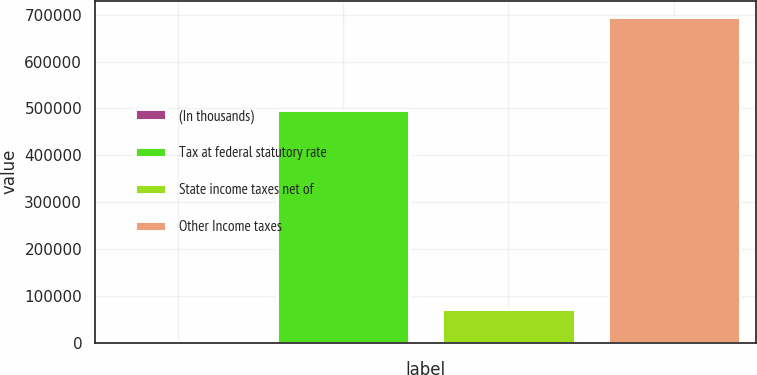<chart> <loc_0><loc_0><loc_500><loc_500><bar_chart><fcel>(In thousands)<fcel>Tax at federal statutory rate<fcel>State income taxes net of<fcel>Other Income taxes<nl><fcel>2017<fcel>495772<fcel>71343.9<fcel>695286<nl></chart> 